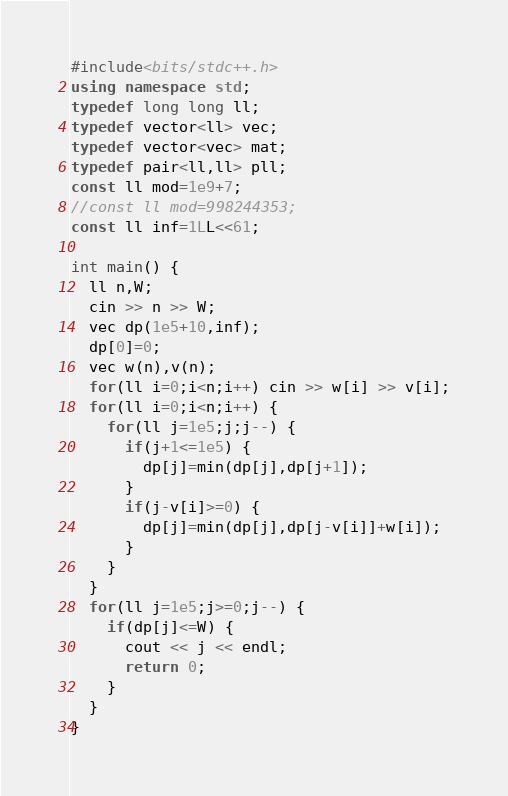Convert code to text. <code><loc_0><loc_0><loc_500><loc_500><_C++_>#include<bits/stdc++.h>
using namespace std;
typedef long long ll;
typedef vector<ll> vec;
typedef vector<vec> mat;
typedef pair<ll,ll> pll;
const ll mod=1e9+7;
//const ll mod=998244353;
const ll inf=1LL<<61;

int main() {
  ll n,W;
  cin >> n >> W;
  vec dp(1e5+10,inf);
  dp[0]=0;
  vec w(n),v(n);
  for(ll i=0;i<n;i++) cin >> w[i] >> v[i];
  for(ll i=0;i<n;i++) {
    for(ll j=1e5;j;j--) {
      if(j+1<=1e5) {
        dp[j]=min(dp[j],dp[j+1]);
      }
      if(j-v[i]>=0) {
        dp[j]=min(dp[j],dp[j-v[i]]+w[i]);
      }
    }
  }
  for(ll j=1e5;j>=0;j--) {
    if(dp[j]<=W) {
      cout << j << endl;
      return 0;
    }
  }
}</code> 